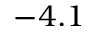<formula> <loc_0><loc_0><loc_500><loc_500>- 4 . 1</formula> 